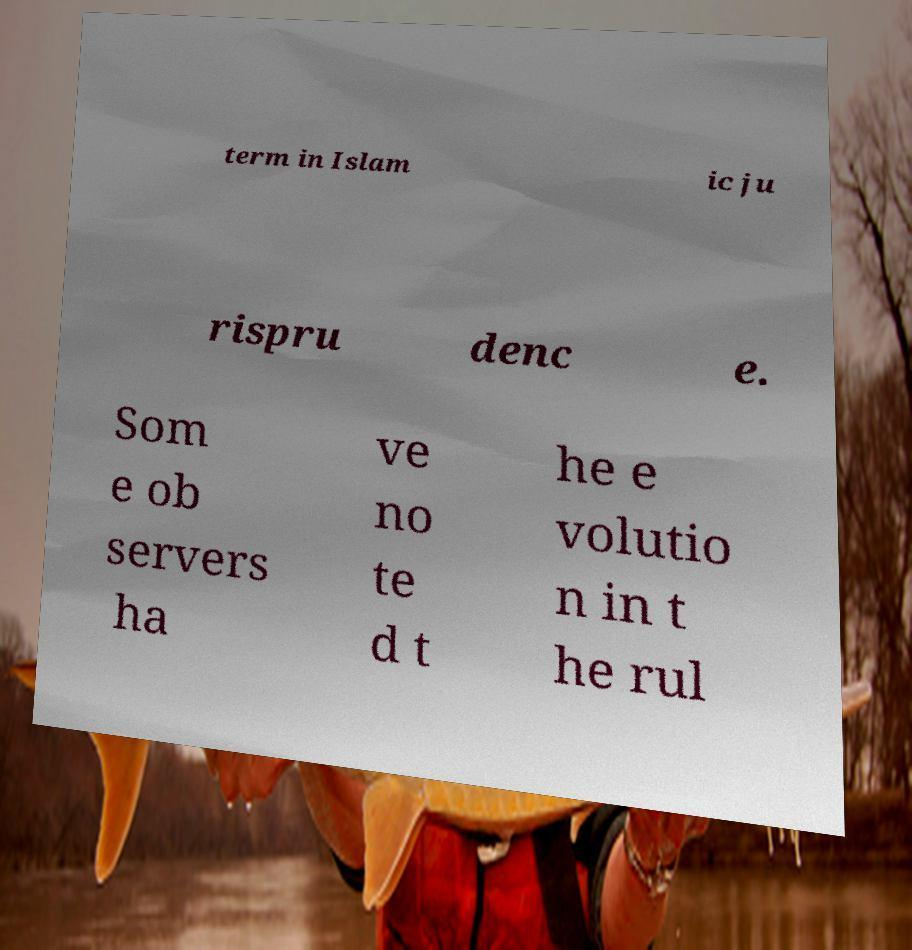Please identify and transcribe the text found in this image. term in Islam ic ju rispru denc e. Som e ob servers ha ve no te d t he e volutio n in t he rul 